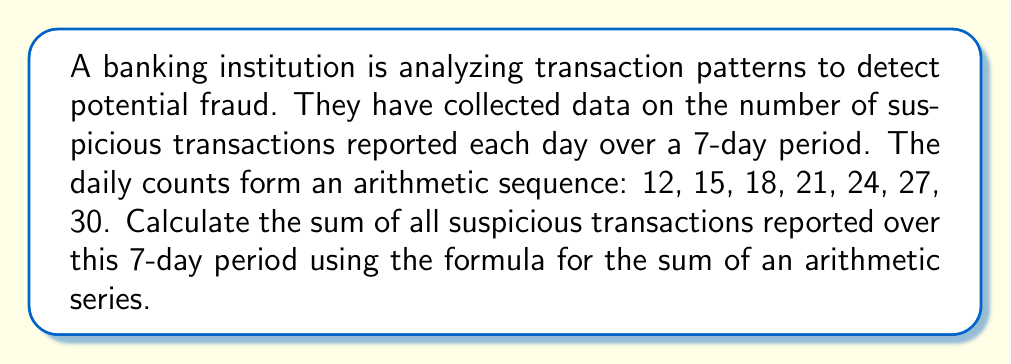Solve this math problem. To solve this problem, we'll use the formula for the sum of an arithmetic series:

$$S_n = \frac{n}{2}(a_1 + a_n)$$

Where:
$S_n$ is the sum of the series
$n$ is the number of terms
$a_1$ is the first term
$a_n$ is the last term

Step 1: Identify the given information
- Number of terms, $n = 7$
- First term, $a_1 = 12$
- Last term, $a_7 = 30$

Step 2: Apply the formula
$$S_7 = \frac{7}{2}(12 + 30)$$

Step 3: Simplify
$$S_7 = \frac{7}{2}(42)$$
$$S_7 = 7 \times 21$$
$$S_7 = 147$$

Therefore, the sum of all suspicious transactions reported over the 7-day period is 147.
Answer: 147 